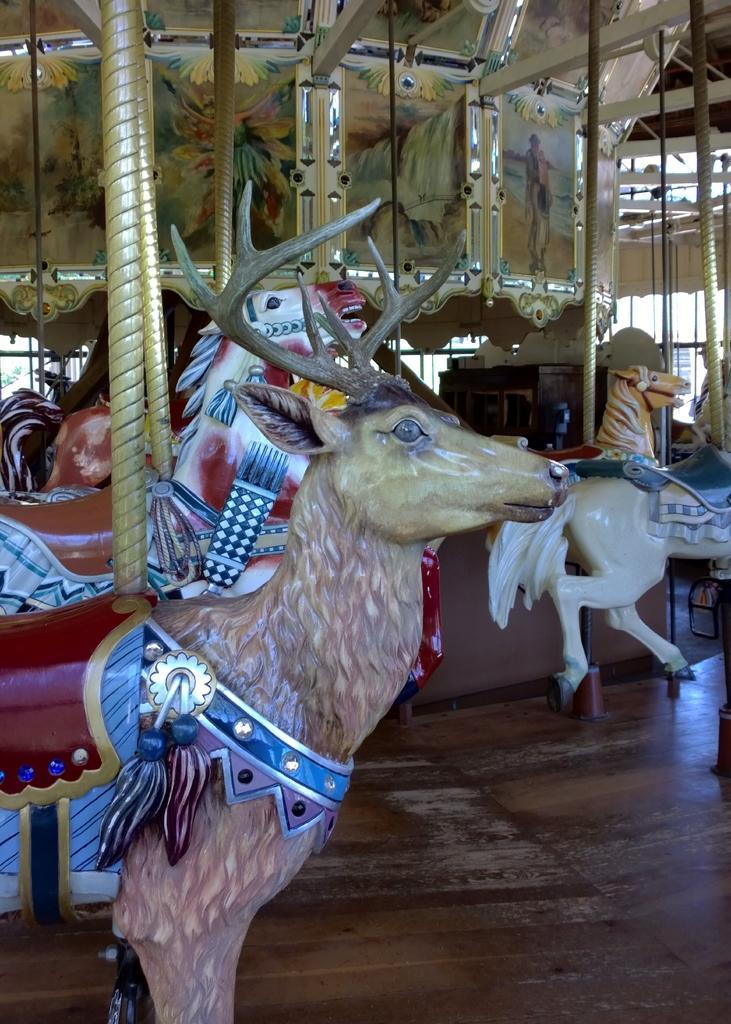Can you describe this image briefly? In this image there are exhibition rides, rods, pictures, wooden floor and objects. 